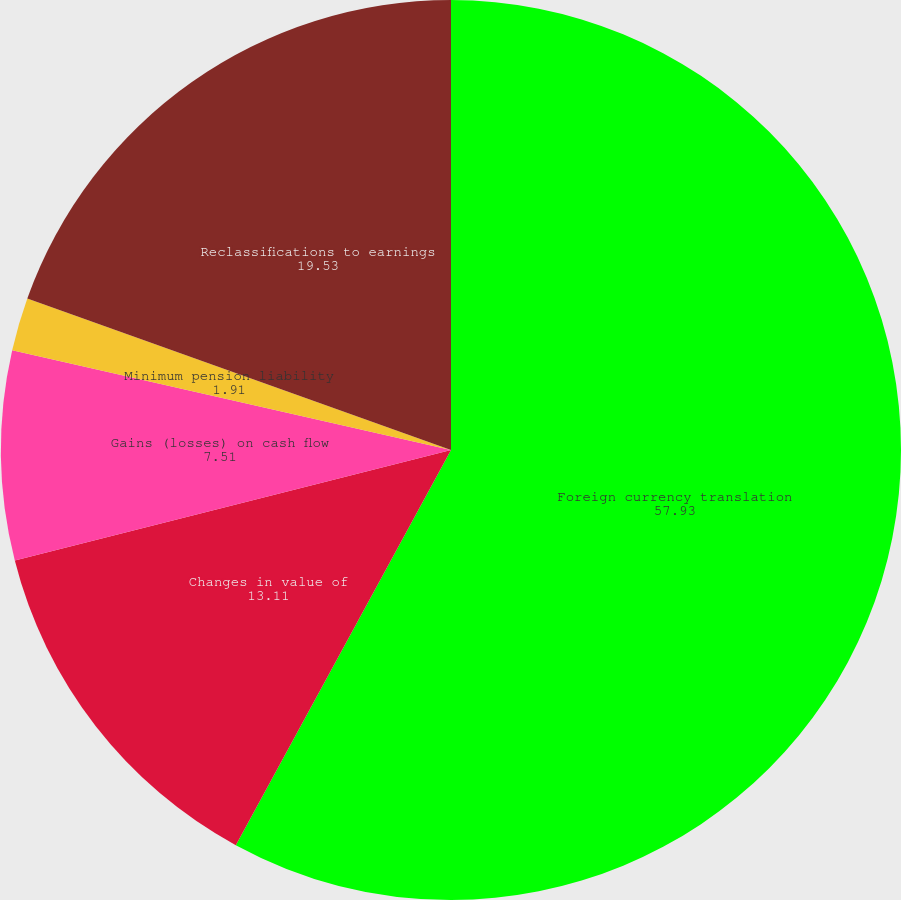Convert chart. <chart><loc_0><loc_0><loc_500><loc_500><pie_chart><fcel>Foreign currency translation<fcel>Changes in value of<fcel>Gains (losses) on cash flow<fcel>Minimum pension liability<fcel>Reclassifications to earnings<nl><fcel>57.93%<fcel>13.11%<fcel>7.51%<fcel>1.91%<fcel>19.53%<nl></chart> 